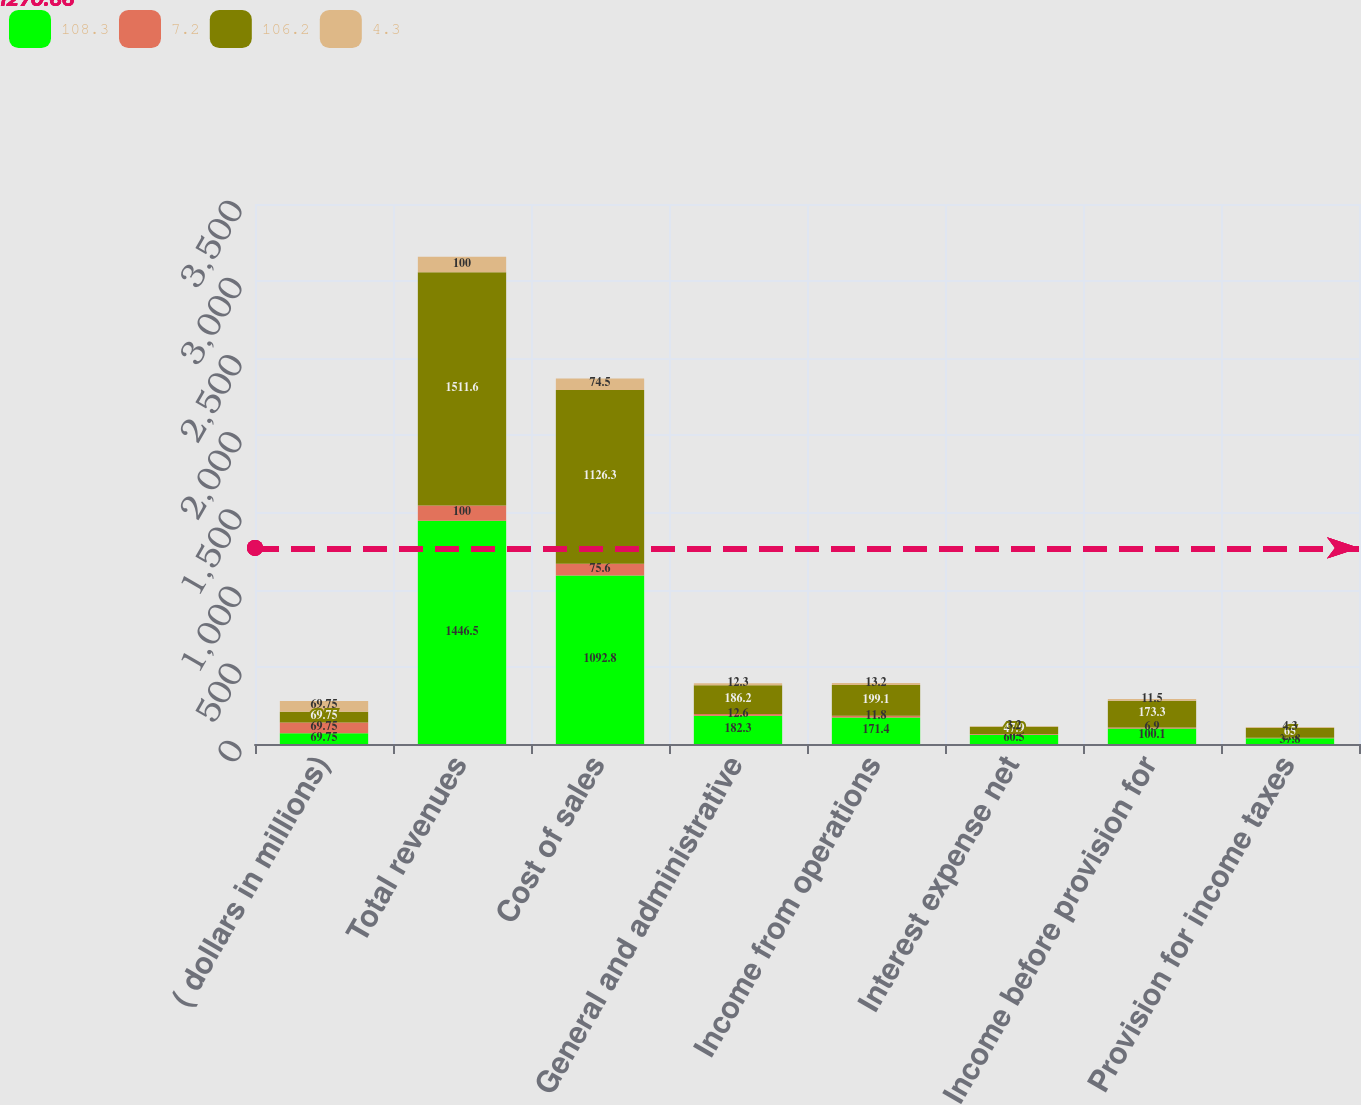Convert chart. <chart><loc_0><loc_0><loc_500><loc_500><stacked_bar_chart><ecel><fcel>( dollars in millions)<fcel>Total revenues<fcel>Cost of sales<fcel>General and administrative<fcel>Income from operations<fcel>Interest expense net<fcel>Income before provision for<fcel>Provision for income taxes<nl><fcel>108.3<fcel>69.75<fcel>1446.5<fcel>1092.8<fcel>182.3<fcel>171.4<fcel>60.5<fcel>100.1<fcel>37.8<nl><fcel>7.2<fcel>69.75<fcel>100<fcel>75.6<fcel>12.6<fcel>11.8<fcel>4.2<fcel>6.9<fcel>2.6<nl><fcel>106.2<fcel>69.75<fcel>1511.6<fcel>1126.3<fcel>186.2<fcel>199.1<fcel>47.9<fcel>173.3<fcel>65<nl><fcel>4.3<fcel>69.75<fcel>100<fcel>74.5<fcel>12.3<fcel>13.2<fcel>3.2<fcel>11.5<fcel>4.3<nl></chart> 